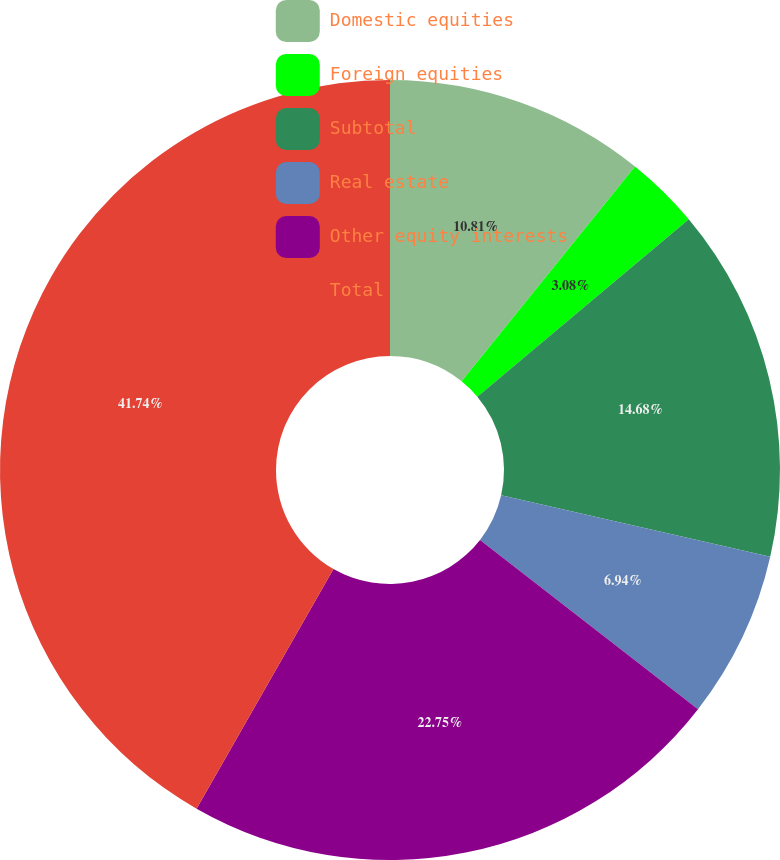Convert chart. <chart><loc_0><loc_0><loc_500><loc_500><pie_chart><fcel>Domestic equities<fcel>Foreign equities<fcel>Subtotal<fcel>Real estate<fcel>Other equity interests<fcel>Total<nl><fcel>10.81%<fcel>3.08%<fcel>14.68%<fcel>6.94%<fcel>22.75%<fcel>41.74%<nl></chart> 